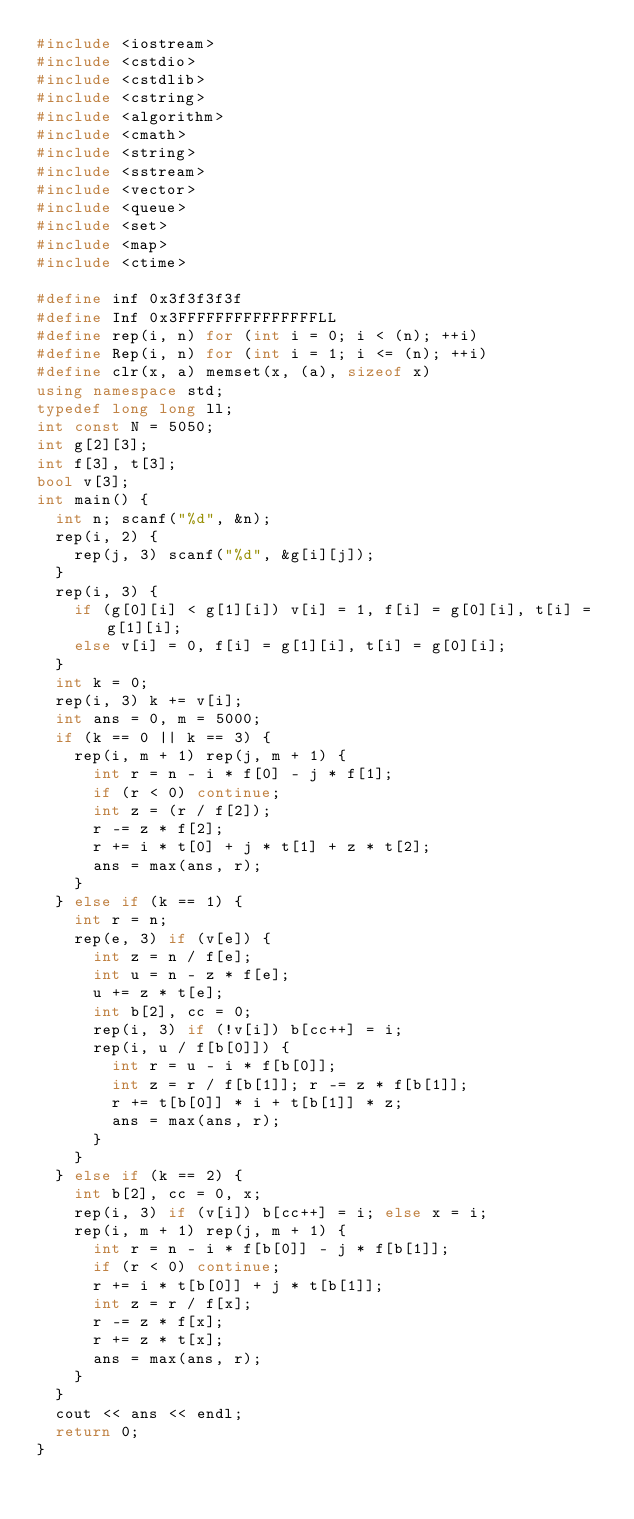Convert code to text. <code><loc_0><loc_0><loc_500><loc_500><_C++_>#include <iostream>
#include <cstdio>
#include <cstdlib>
#include <cstring>
#include <algorithm>
#include <cmath>
#include <string>
#include <sstream>
#include <vector>
#include <queue>
#include <set>
#include <map>
#include <ctime>

#define inf 0x3f3f3f3f
#define Inf 0x3FFFFFFFFFFFFFFFLL
#define rep(i, n) for (int i = 0; i < (n); ++i)
#define Rep(i, n) for (int i = 1; i <= (n); ++i)
#define clr(x, a) memset(x, (a), sizeof x)
using namespace std;
typedef long long ll;
int const N = 5050;
int g[2][3];
int f[3], t[3];
bool v[3];
int main() {
  int n; scanf("%d", &n);
  rep(i, 2) {
    rep(j, 3) scanf("%d", &g[i][j]);
  }
  rep(i, 3) {
    if (g[0][i] < g[1][i]) v[i] = 1, f[i] = g[0][i], t[i] = g[1][i];
    else v[i] = 0, f[i] = g[1][i], t[i] = g[0][i];
  }
  int k = 0;
  rep(i, 3) k += v[i];
  int ans = 0, m = 5000;
  if (k == 0 || k == 3) {
    rep(i, m + 1) rep(j, m + 1) {
      int r = n - i * f[0] - j * f[1];
      if (r < 0) continue;
      int z = (r / f[2]);
      r -= z * f[2];
      r += i * t[0] + j * t[1] + z * t[2];
      ans = max(ans, r);
    }
  } else if (k == 1) {
    int r = n;
    rep(e, 3) if (v[e]) {
      int z = n / f[e];
      int u = n - z * f[e];
      u += z * t[e];
      int b[2], cc = 0;
      rep(i, 3) if (!v[i]) b[cc++] = i;
      rep(i, u / f[b[0]]) {
        int r = u - i * f[b[0]];
        int z = r / f[b[1]]; r -= z * f[b[1]];
        r += t[b[0]] * i + t[b[1]] * z;
        ans = max(ans, r);
      }
    }
  } else if (k == 2) {
    int b[2], cc = 0, x;
    rep(i, 3) if (v[i]) b[cc++] = i; else x = i;
    rep(i, m + 1) rep(j, m + 1) {
      int r = n - i * f[b[0]] - j * f[b[1]];
      if (r < 0) continue;
      r += i * t[b[0]] + j * t[b[1]];
      int z = r / f[x];
      r -= z * f[x];
      r += z * t[x];
      ans = max(ans, r);
    }
  }
  cout << ans << endl;
  return 0;
}

</code> 